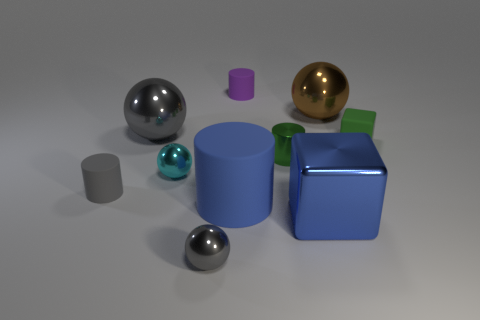Is the number of large metallic cubes behind the small green metal cylinder less than the number of gray rubber cylinders that are behind the purple object?
Your answer should be compact. No. Is the shape of the green metal thing the same as the small green matte object?
Your answer should be very brief. No. How many other objects are the same size as the gray matte cylinder?
Give a very brief answer. 5. How many objects are objects behind the cyan shiny object or large things behind the metallic cube?
Make the answer very short. 6. What number of small purple rubber things have the same shape as the cyan shiny object?
Your answer should be very brief. 0. The sphere that is both to the right of the tiny cyan thing and behind the green rubber block is made of what material?
Your answer should be very brief. Metal. There is a gray cylinder; what number of small matte things are right of it?
Offer a very short reply. 2. How many small metal objects are there?
Provide a short and direct response. 3. Is the green matte thing the same size as the blue rubber thing?
Make the answer very short. No. Is there a blue object behind the small cyan ball that is in front of the green thing that is in front of the green rubber thing?
Give a very brief answer. No. 